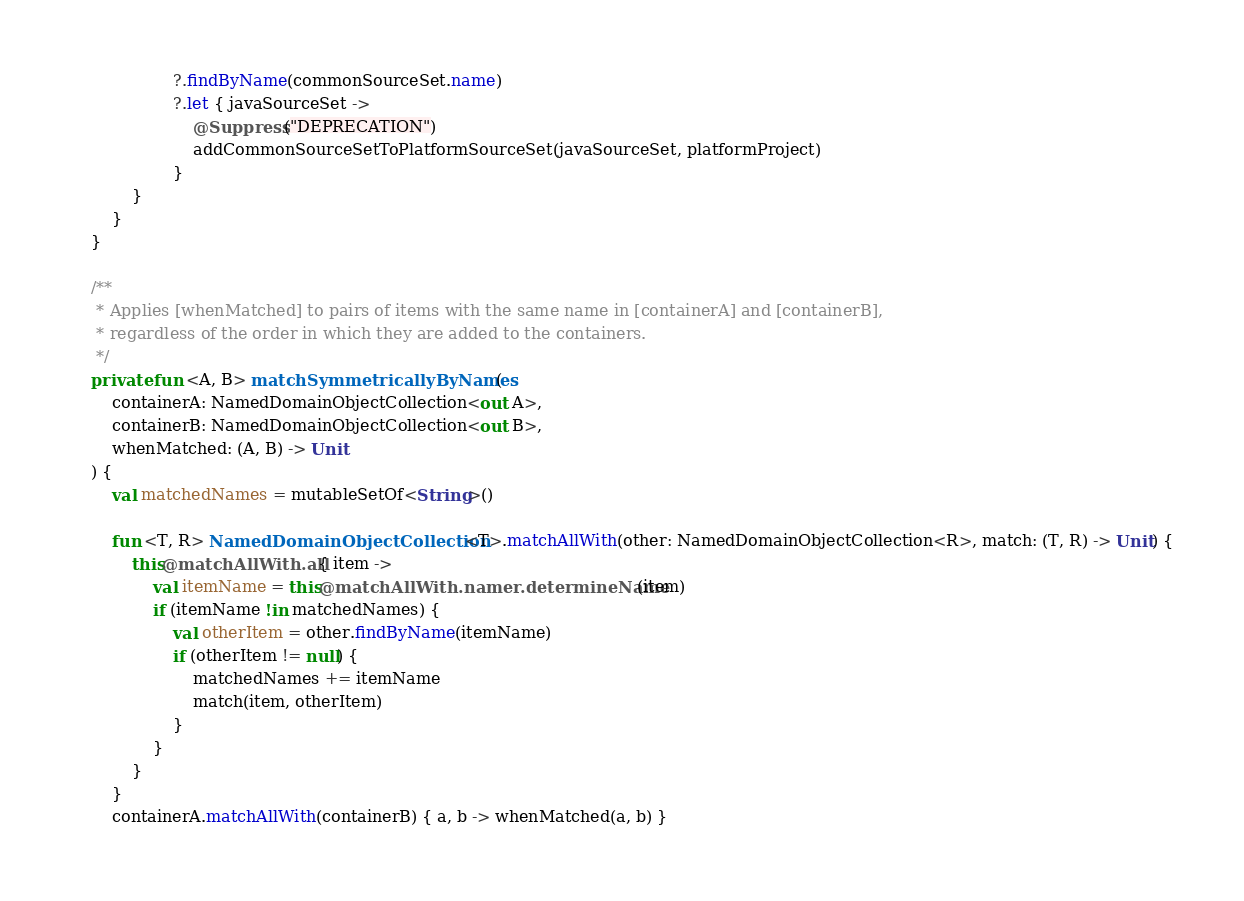Convert code to text. <code><loc_0><loc_0><loc_500><loc_500><_Kotlin_>                    ?.findByName(commonSourceSet.name)
                    ?.let { javaSourceSet ->
                        @Suppress("DEPRECATION")
                        addCommonSourceSetToPlatformSourceSet(javaSourceSet, platformProject)
                    }
            }
        }
    }

    /**
     * Applies [whenMatched] to pairs of items with the same name in [containerA] and [containerB],
     * regardless of the order in which they are added to the containers.
     */
    private fun <A, B> matchSymmetricallyByNames(
        containerA: NamedDomainObjectCollection<out A>,
        containerB: NamedDomainObjectCollection<out B>,
        whenMatched: (A, B) -> Unit
    ) {
        val matchedNames = mutableSetOf<String>()

        fun <T, R> NamedDomainObjectCollection<T>.matchAllWith(other: NamedDomainObjectCollection<R>, match: (T, R) -> Unit) {
            this@matchAllWith.all { item ->
                val itemName = this@matchAllWith.namer.determineName(item)
                if (itemName !in matchedNames) {
                    val otherItem = other.findByName(itemName)
                    if (otherItem != null) {
                        matchedNames += itemName
                        match(item, otherItem)
                    }
                }
            }
        }
        containerA.matchAllWith(containerB) { a, b -> whenMatched(a, b) }</code> 